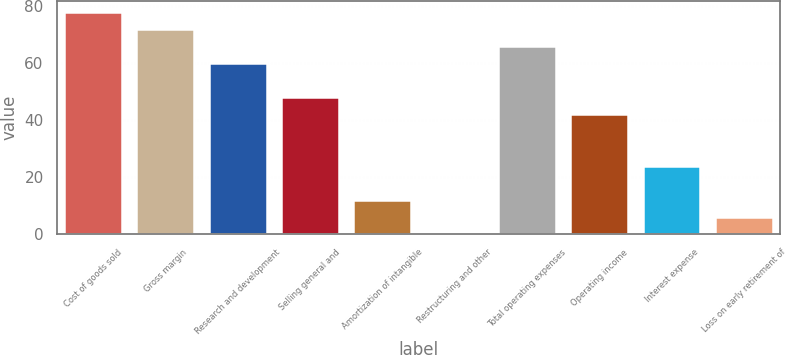Convert chart. <chart><loc_0><loc_0><loc_500><loc_500><bar_chart><fcel>Cost of goods sold<fcel>Gross margin<fcel>Research and development<fcel>Selling general and<fcel>Amortization of intangible<fcel>Restructuring and other<fcel>Total operating expenses<fcel>Operating income<fcel>Interest expense<fcel>Loss on early retirement of<nl><fcel>78.1<fcel>72.1<fcel>60.1<fcel>48.1<fcel>12.1<fcel>0.1<fcel>66.1<fcel>42.1<fcel>24.1<fcel>6.1<nl></chart> 